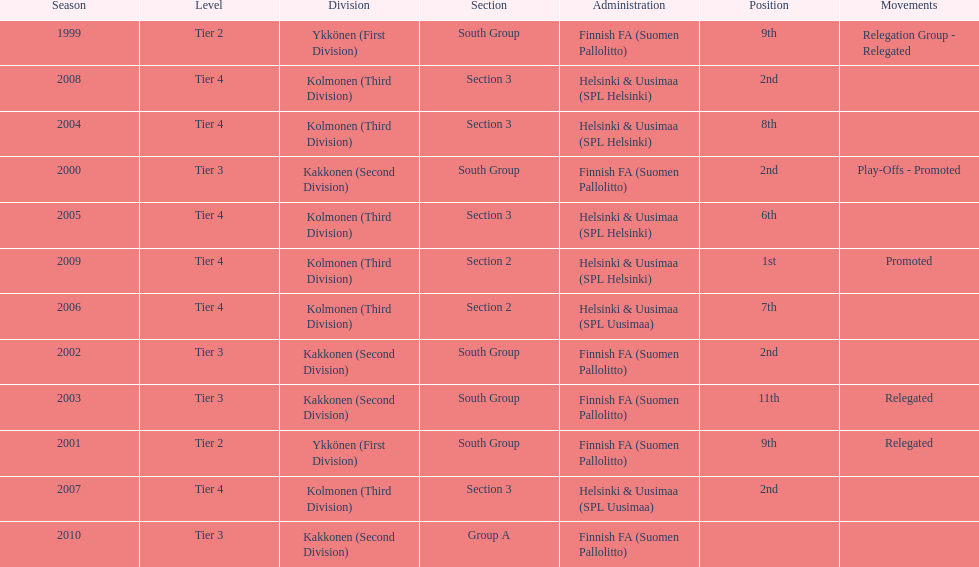Which was the only kolmonen whose movements were promoted? 2009. 